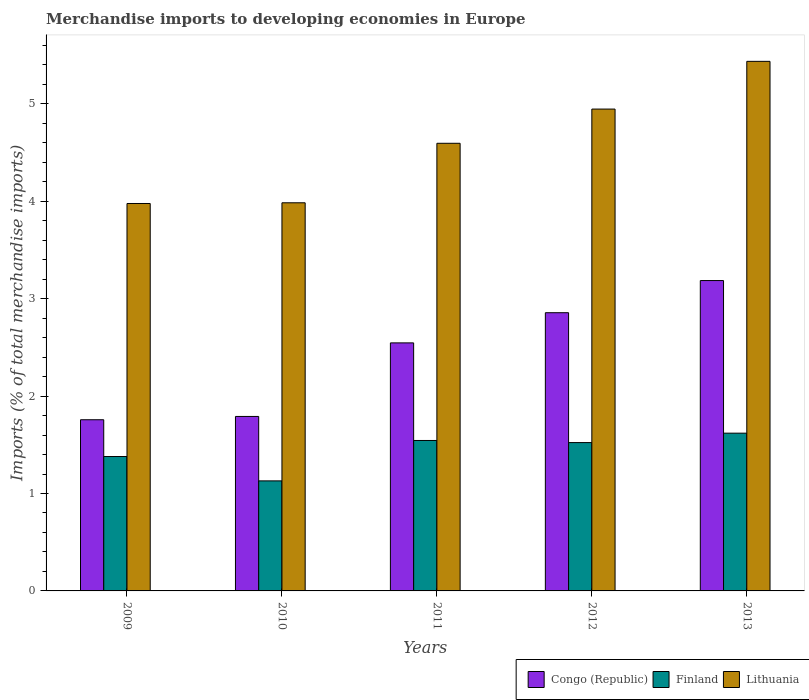How many different coloured bars are there?
Offer a terse response. 3. Are the number of bars on each tick of the X-axis equal?
Offer a terse response. Yes. What is the label of the 1st group of bars from the left?
Your answer should be compact. 2009. What is the percentage total merchandise imports in Finland in 2011?
Make the answer very short. 1.54. Across all years, what is the maximum percentage total merchandise imports in Finland?
Make the answer very short. 1.62. Across all years, what is the minimum percentage total merchandise imports in Lithuania?
Your answer should be very brief. 3.98. In which year was the percentage total merchandise imports in Finland minimum?
Ensure brevity in your answer.  2010. What is the total percentage total merchandise imports in Lithuania in the graph?
Give a very brief answer. 22.94. What is the difference between the percentage total merchandise imports in Finland in 2012 and that in 2013?
Your response must be concise. -0.1. What is the difference between the percentage total merchandise imports in Congo (Republic) in 2011 and the percentage total merchandise imports in Lithuania in 2009?
Offer a terse response. -1.43. What is the average percentage total merchandise imports in Congo (Republic) per year?
Your response must be concise. 2.43. In the year 2011, what is the difference between the percentage total merchandise imports in Lithuania and percentage total merchandise imports in Finland?
Ensure brevity in your answer.  3.05. In how many years, is the percentage total merchandise imports in Lithuania greater than 2 %?
Offer a terse response. 5. What is the ratio of the percentage total merchandise imports in Congo (Republic) in 2009 to that in 2013?
Provide a succinct answer. 0.55. Is the percentage total merchandise imports in Congo (Republic) in 2009 less than that in 2012?
Your answer should be very brief. Yes. What is the difference between the highest and the second highest percentage total merchandise imports in Congo (Republic)?
Provide a short and direct response. 0.33. What is the difference between the highest and the lowest percentage total merchandise imports in Finland?
Your answer should be compact. 0.49. Is the sum of the percentage total merchandise imports in Finland in 2011 and 2013 greater than the maximum percentage total merchandise imports in Lithuania across all years?
Offer a terse response. No. What does the 3rd bar from the left in 2010 represents?
Offer a terse response. Lithuania. What does the 3rd bar from the right in 2012 represents?
Your answer should be compact. Congo (Republic). Is it the case that in every year, the sum of the percentage total merchandise imports in Congo (Republic) and percentage total merchandise imports in Finland is greater than the percentage total merchandise imports in Lithuania?
Your answer should be compact. No. How are the legend labels stacked?
Offer a terse response. Horizontal. What is the title of the graph?
Ensure brevity in your answer.  Merchandise imports to developing economies in Europe. Does "Syrian Arab Republic" appear as one of the legend labels in the graph?
Give a very brief answer. No. What is the label or title of the X-axis?
Ensure brevity in your answer.  Years. What is the label or title of the Y-axis?
Make the answer very short. Imports (% of total merchandise imports). What is the Imports (% of total merchandise imports) of Congo (Republic) in 2009?
Provide a succinct answer. 1.76. What is the Imports (% of total merchandise imports) in Finland in 2009?
Keep it short and to the point. 1.38. What is the Imports (% of total merchandise imports) in Lithuania in 2009?
Offer a terse response. 3.98. What is the Imports (% of total merchandise imports) in Congo (Republic) in 2010?
Make the answer very short. 1.79. What is the Imports (% of total merchandise imports) of Finland in 2010?
Your answer should be very brief. 1.13. What is the Imports (% of total merchandise imports) of Lithuania in 2010?
Give a very brief answer. 3.98. What is the Imports (% of total merchandise imports) in Congo (Republic) in 2011?
Offer a terse response. 2.55. What is the Imports (% of total merchandise imports) of Finland in 2011?
Provide a succinct answer. 1.54. What is the Imports (% of total merchandise imports) of Lithuania in 2011?
Ensure brevity in your answer.  4.6. What is the Imports (% of total merchandise imports) of Congo (Republic) in 2012?
Give a very brief answer. 2.86. What is the Imports (% of total merchandise imports) in Finland in 2012?
Your answer should be very brief. 1.52. What is the Imports (% of total merchandise imports) of Lithuania in 2012?
Provide a short and direct response. 4.95. What is the Imports (% of total merchandise imports) in Congo (Republic) in 2013?
Keep it short and to the point. 3.19. What is the Imports (% of total merchandise imports) in Finland in 2013?
Your answer should be very brief. 1.62. What is the Imports (% of total merchandise imports) in Lithuania in 2013?
Ensure brevity in your answer.  5.44. Across all years, what is the maximum Imports (% of total merchandise imports) in Congo (Republic)?
Make the answer very short. 3.19. Across all years, what is the maximum Imports (% of total merchandise imports) in Finland?
Provide a succinct answer. 1.62. Across all years, what is the maximum Imports (% of total merchandise imports) in Lithuania?
Offer a very short reply. 5.44. Across all years, what is the minimum Imports (% of total merchandise imports) of Congo (Republic)?
Give a very brief answer. 1.76. Across all years, what is the minimum Imports (% of total merchandise imports) in Finland?
Provide a succinct answer. 1.13. Across all years, what is the minimum Imports (% of total merchandise imports) of Lithuania?
Give a very brief answer. 3.98. What is the total Imports (% of total merchandise imports) in Congo (Republic) in the graph?
Offer a very short reply. 12.14. What is the total Imports (% of total merchandise imports) of Finland in the graph?
Provide a short and direct response. 7.2. What is the total Imports (% of total merchandise imports) in Lithuania in the graph?
Your answer should be very brief. 22.94. What is the difference between the Imports (% of total merchandise imports) in Congo (Republic) in 2009 and that in 2010?
Offer a very short reply. -0.03. What is the difference between the Imports (% of total merchandise imports) of Lithuania in 2009 and that in 2010?
Provide a short and direct response. -0.01. What is the difference between the Imports (% of total merchandise imports) of Congo (Republic) in 2009 and that in 2011?
Offer a terse response. -0.79. What is the difference between the Imports (% of total merchandise imports) of Finland in 2009 and that in 2011?
Your response must be concise. -0.16. What is the difference between the Imports (% of total merchandise imports) of Lithuania in 2009 and that in 2011?
Offer a very short reply. -0.62. What is the difference between the Imports (% of total merchandise imports) of Congo (Republic) in 2009 and that in 2012?
Offer a terse response. -1.1. What is the difference between the Imports (% of total merchandise imports) of Finland in 2009 and that in 2012?
Provide a succinct answer. -0.14. What is the difference between the Imports (% of total merchandise imports) of Lithuania in 2009 and that in 2012?
Ensure brevity in your answer.  -0.97. What is the difference between the Imports (% of total merchandise imports) of Congo (Republic) in 2009 and that in 2013?
Your response must be concise. -1.43. What is the difference between the Imports (% of total merchandise imports) in Finland in 2009 and that in 2013?
Ensure brevity in your answer.  -0.24. What is the difference between the Imports (% of total merchandise imports) of Lithuania in 2009 and that in 2013?
Your answer should be very brief. -1.46. What is the difference between the Imports (% of total merchandise imports) of Congo (Republic) in 2010 and that in 2011?
Provide a short and direct response. -0.76. What is the difference between the Imports (% of total merchandise imports) of Finland in 2010 and that in 2011?
Your response must be concise. -0.41. What is the difference between the Imports (% of total merchandise imports) in Lithuania in 2010 and that in 2011?
Ensure brevity in your answer.  -0.61. What is the difference between the Imports (% of total merchandise imports) of Congo (Republic) in 2010 and that in 2012?
Your answer should be very brief. -1.06. What is the difference between the Imports (% of total merchandise imports) of Finland in 2010 and that in 2012?
Give a very brief answer. -0.39. What is the difference between the Imports (% of total merchandise imports) in Lithuania in 2010 and that in 2012?
Your answer should be compact. -0.96. What is the difference between the Imports (% of total merchandise imports) in Congo (Republic) in 2010 and that in 2013?
Keep it short and to the point. -1.39. What is the difference between the Imports (% of total merchandise imports) in Finland in 2010 and that in 2013?
Make the answer very short. -0.49. What is the difference between the Imports (% of total merchandise imports) of Lithuania in 2010 and that in 2013?
Offer a terse response. -1.45. What is the difference between the Imports (% of total merchandise imports) of Congo (Republic) in 2011 and that in 2012?
Offer a very short reply. -0.31. What is the difference between the Imports (% of total merchandise imports) of Finland in 2011 and that in 2012?
Your answer should be very brief. 0.02. What is the difference between the Imports (% of total merchandise imports) of Lithuania in 2011 and that in 2012?
Ensure brevity in your answer.  -0.35. What is the difference between the Imports (% of total merchandise imports) of Congo (Republic) in 2011 and that in 2013?
Provide a short and direct response. -0.64. What is the difference between the Imports (% of total merchandise imports) of Finland in 2011 and that in 2013?
Your answer should be very brief. -0.08. What is the difference between the Imports (% of total merchandise imports) of Lithuania in 2011 and that in 2013?
Provide a short and direct response. -0.84. What is the difference between the Imports (% of total merchandise imports) in Congo (Republic) in 2012 and that in 2013?
Your answer should be very brief. -0.33. What is the difference between the Imports (% of total merchandise imports) in Finland in 2012 and that in 2013?
Provide a short and direct response. -0.1. What is the difference between the Imports (% of total merchandise imports) of Lithuania in 2012 and that in 2013?
Offer a terse response. -0.49. What is the difference between the Imports (% of total merchandise imports) of Congo (Republic) in 2009 and the Imports (% of total merchandise imports) of Finland in 2010?
Your answer should be very brief. 0.63. What is the difference between the Imports (% of total merchandise imports) of Congo (Republic) in 2009 and the Imports (% of total merchandise imports) of Lithuania in 2010?
Give a very brief answer. -2.23. What is the difference between the Imports (% of total merchandise imports) of Finland in 2009 and the Imports (% of total merchandise imports) of Lithuania in 2010?
Offer a very short reply. -2.6. What is the difference between the Imports (% of total merchandise imports) of Congo (Republic) in 2009 and the Imports (% of total merchandise imports) of Finland in 2011?
Your answer should be very brief. 0.21. What is the difference between the Imports (% of total merchandise imports) of Congo (Republic) in 2009 and the Imports (% of total merchandise imports) of Lithuania in 2011?
Your answer should be very brief. -2.84. What is the difference between the Imports (% of total merchandise imports) in Finland in 2009 and the Imports (% of total merchandise imports) in Lithuania in 2011?
Ensure brevity in your answer.  -3.22. What is the difference between the Imports (% of total merchandise imports) of Congo (Republic) in 2009 and the Imports (% of total merchandise imports) of Finland in 2012?
Provide a succinct answer. 0.23. What is the difference between the Imports (% of total merchandise imports) of Congo (Republic) in 2009 and the Imports (% of total merchandise imports) of Lithuania in 2012?
Provide a succinct answer. -3.19. What is the difference between the Imports (% of total merchandise imports) of Finland in 2009 and the Imports (% of total merchandise imports) of Lithuania in 2012?
Your answer should be compact. -3.57. What is the difference between the Imports (% of total merchandise imports) in Congo (Republic) in 2009 and the Imports (% of total merchandise imports) in Finland in 2013?
Provide a succinct answer. 0.14. What is the difference between the Imports (% of total merchandise imports) in Congo (Republic) in 2009 and the Imports (% of total merchandise imports) in Lithuania in 2013?
Make the answer very short. -3.68. What is the difference between the Imports (% of total merchandise imports) in Finland in 2009 and the Imports (% of total merchandise imports) in Lithuania in 2013?
Make the answer very short. -4.06. What is the difference between the Imports (% of total merchandise imports) in Congo (Republic) in 2010 and the Imports (% of total merchandise imports) in Finland in 2011?
Keep it short and to the point. 0.25. What is the difference between the Imports (% of total merchandise imports) of Congo (Republic) in 2010 and the Imports (% of total merchandise imports) of Lithuania in 2011?
Keep it short and to the point. -2.8. What is the difference between the Imports (% of total merchandise imports) in Finland in 2010 and the Imports (% of total merchandise imports) in Lithuania in 2011?
Your answer should be compact. -3.47. What is the difference between the Imports (% of total merchandise imports) of Congo (Republic) in 2010 and the Imports (% of total merchandise imports) of Finland in 2012?
Offer a terse response. 0.27. What is the difference between the Imports (% of total merchandise imports) in Congo (Republic) in 2010 and the Imports (% of total merchandise imports) in Lithuania in 2012?
Ensure brevity in your answer.  -3.16. What is the difference between the Imports (% of total merchandise imports) of Finland in 2010 and the Imports (% of total merchandise imports) of Lithuania in 2012?
Keep it short and to the point. -3.82. What is the difference between the Imports (% of total merchandise imports) in Congo (Republic) in 2010 and the Imports (% of total merchandise imports) in Finland in 2013?
Your answer should be very brief. 0.17. What is the difference between the Imports (% of total merchandise imports) of Congo (Republic) in 2010 and the Imports (% of total merchandise imports) of Lithuania in 2013?
Your response must be concise. -3.65. What is the difference between the Imports (% of total merchandise imports) in Finland in 2010 and the Imports (% of total merchandise imports) in Lithuania in 2013?
Your answer should be very brief. -4.31. What is the difference between the Imports (% of total merchandise imports) of Congo (Republic) in 2011 and the Imports (% of total merchandise imports) of Finland in 2012?
Your response must be concise. 1.02. What is the difference between the Imports (% of total merchandise imports) of Congo (Republic) in 2011 and the Imports (% of total merchandise imports) of Lithuania in 2012?
Keep it short and to the point. -2.4. What is the difference between the Imports (% of total merchandise imports) in Finland in 2011 and the Imports (% of total merchandise imports) in Lithuania in 2012?
Make the answer very short. -3.4. What is the difference between the Imports (% of total merchandise imports) in Congo (Republic) in 2011 and the Imports (% of total merchandise imports) in Finland in 2013?
Keep it short and to the point. 0.93. What is the difference between the Imports (% of total merchandise imports) in Congo (Republic) in 2011 and the Imports (% of total merchandise imports) in Lithuania in 2013?
Your answer should be compact. -2.89. What is the difference between the Imports (% of total merchandise imports) in Finland in 2011 and the Imports (% of total merchandise imports) in Lithuania in 2013?
Ensure brevity in your answer.  -3.89. What is the difference between the Imports (% of total merchandise imports) of Congo (Republic) in 2012 and the Imports (% of total merchandise imports) of Finland in 2013?
Your answer should be compact. 1.24. What is the difference between the Imports (% of total merchandise imports) of Congo (Republic) in 2012 and the Imports (% of total merchandise imports) of Lithuania in 2013?
Offer a terse response. -2.58. What is the difference between the Imports (% of total merchandise imports) of Finland in 2012 and the Imports (% of total merchandise imports) of Lithuania in 2013?
Ensure brevity in your answer.  -3.91. What is the average Imports (% of total merchandise imports) of Congo (Republic) per year?
Your answer should be compact. 2.43. What is the average Imports (% of total merchandise imports) in Finland per year?
Provide a succinct answer. 1.44. What is the average Imports (% of total merchandise imports) in Lithuania per year?
Your response must be concise. 4.59. In the year 2009, what is the difference between the Imports (% of total merchandise imports) in Congo (Republic) and Imports (% of total merchandise imports) in Finland?
Give a very brief answer. 0.38. In the year 2009, what is the difference between the Imports (% of total merchandise imports) in Congo (Republic) and Imports (% of total merchandise imports) in Lithuania?
Keep it short and to the point. -2.22. In the year 2009, what is the difference between the Imports (% of total merchandise imports) of Finland and Imports (% of total merchandise imports) of Lithuania?
Offer a terse response. -2.6. In the year 2010, what is the difference between the Imports (% of total merchandise imports) of Congo (Republic) and Imports (% of total merchandise imports) of Finland?
Ensure brevity in your answer.  0.66. In the year 2010, what is the difference between the Imports (% of total merchandise imports) of Congo (Republic) and Imports (% of total merchandise imports) of Lithuania?
Keep it short and to the point. -2.19. In the year 2010, what is the difference between the Imports (% of total merchandise imports) of Finland and Imports (% of total merchandise imports) of Lithuania?
Make the answer very short. -2.85. In the year 2011, what is the difference between the Imports (% of total merchandise imports) in Congo (Republic) and Imports (% of total merchandise imports) in Lithuania?
Keep it short and to the point. -2.05. In the year 2011, what is the difference between the Imports (% of total merchandise imports) of Finland and Imports (% of total merchandise imports) of Lithuania?
Offer a terse response. -3.05. In the year 2012, what is the difference between the Imports (% of total merchandise imports) in Congo (Republic) and Imports (% of total merchandise imports) in Finland?
Keep it short and to the point. 1.33. In the year 2012, what is the difference between the Imports (% of total merchandise imports) of Congo (Republic) and Imports (% of total merchandise imports) of Lithuania?
Give a very brief answer. -2.09. In the year 2012, what is the difference between the Imports (% of total merchandise imports) in Finland and Imports (% of total merchandise imports) in Lithuania?
Provide a succinct answer. -3.42. In the year 2013, what is the difference between the Imports (% of total merchandise imports) of Congo (Republic) and Imports (% of total merchandise imports) of Finland?
Provide a short and direct response. 1.57. In the year 2013, what is the difference between the Imports (% of total merchandise imports) of Congo (Republic) and Imports (% of total merchandise imports) of Lithuania?
Give a very brief answer. -2.25. In the year 2013, what is the difference between the Imports (% of total merchandise imports) of Finland and Imports (% of total merchandise imports) of Lithuania?
Keep it short and to the point. -3.82. What is the ratio of the Imports (% of total merchandise imports) of Congo (Republic) in 2009 to that in 2010?
Provide a short and direct response. 0.98. What is the ratio of the Imports (% of total merchandise imports) in Finland in 2009 to that in 2010?
Your answer should be compact. 1.22. What is the ratio of the Imports (% of total merchandise imports) of Congo (Republic) in 2009 to that in 2011?
Ensure brevity in your answer.  0.69. What is the ratio of the Imports (% of total merchandise imports) in Finland in 2009 to that in 2011?
Your answer should be compact. 0.89. What is the ratio of the Imports (% of total merchandise imports) in Lithuania in 2009 to that in 2011?
Offer a terse response. 0.87. What is the ratio of the Imports (% of total merchandise imports) in Congo (Republic) in 2009 to that in 2012?
Your answer should be very brief. 0.62. What is the ratio of the Imports (% of total merchandise imports) in Finland in 2009 to that in 2012?
Give a very brief answer. 0.91. What is the ratio of the Imports (% of total merchandise imports) in Lithuania in 2009 to that in 2012?
Your answer should be very brief. 0.8. What is the ratio of the Imports (% of total merchandise imports) in Congo (Republic) in 2009 to that in 2013?
Provide a succinct answer. 0.55. What is the ratio of the Imports (% of total merchandise imports) of Finland in 2009 to that in 2013?
Your response must be concise. 0.85. What is the ratio of the Imports (% of total merchandise imports) in Lithuania in 2009 to that in 2013?
Your answer should be very brief. 0.73. What is the ratio of the Imports (% of total merchandise imports) of Congo (Republic) in 2010 to that in 2011?
Provide a short and direct response. 0.7. What is the ratio of the Imports (% of total merchandise imports) of Finland in 2010 to that in 2011?
Offer a terse response. 0.73. What is the ratio of the Imports (% of total merchandise imports) of Lithuania in 2010 to that in 2011?
Ensure brevity in your answer.  0.87. What is the ratio of the Imports (% of total merchandise imports) of Congo (Republic) in 2010 to that in 2012?
Provide a short and direct response. 0.63. What is the ratio of the Imports (% of total merchandise imports) of Finland in 2010 to that in 2012?
Your answer should be very brief. 0.74. What is the ratio of the Imports (% of total merchandise imports) in Lithuania in 2010 to that in 2012?
Your response must be concise. 0.81. What is the ratio of the Imports (% of total merchandise imports) in Congo (Republic) in 2010 to that in 2013?
Offer a very short reply. 0.56. What is the ratio of the Imports (% of total merchandise imports) of Finland in 2010 to that in 2013?
Offer a very short reply. 0.7. What is the ratio of the Imports (% of total merchandise imports) of Lithuania in 2010 to that in 2013?
Make the answer very short. 0.73. What is the ratio of the Imports (% of total merchandise imports) of Congo (Republic) in 2011 to that in 2012?
Provide a succinct answer. 0.89. What is the ratio of the Imports (% of total merchandise imports) of Finland in 2011 to that in 2012?
Give a very brief answer. 1.01. What is the ratio of the Imports (% of total merchandise imports) of Lithuania in 2011 to that in 2012?
Your response must be concise. 0.93. What is the ratio of the Imports (% of total merchandise imports) of Congo (Republic) in 2011 to that in 2013?
Provide a succinct answer. 0.8. What is the ratio of the Imports (% of total merchandise imports) of Finland in 2011 to that in 2013?
Make the answer very short. 0.95. What is the ratio of the Imports (% of total merchandise imports) of Lithuania in 2011 to that in 2013?
Make the answer very short. 0.85. What is the ratio of the Imports (% of total merchandise imports) of Congo (Republic) in 2012 to that in 2013?
Offer a very short reply. 0.9. What is the ratio of the Imports (% of total merchandise imports) of Finland in 2012 to that in 2013?
Offer a terse response. 0.94. What is the ratio of the Imports (% of total merchandise imports) of Lithuania in 2012 to that in 2013?
Your answer should be very brief. 0.91. What is the difference between the highest and the second highest Imports (% of total merchandise imports) of Congo (Republic)?
Give a very brief answer. 0.33. What is the difference between the highest and the second highest Imports (% of total merchandise imports) of Finland?
Provide a succinct answer. 0.08. What is the difference between the highest and the second highest Imports (% of total merchandise imports) of Lithuania?
Provide a short and direct response. 0.49. What is the difference between the highest and the lowest Imports (% of total merchandise imports) in Congo (Republic)?
Give a very brief answer. 1.43. What is the difference between the highest and the lowest Imports (% of total merchandise imports) in Finland?
Make the answer very short. 0.49. What is the difference between the highest and the lowest Imports (% of total merchandise imports) of Lithuania?
Make the answer very short. 1.46. 